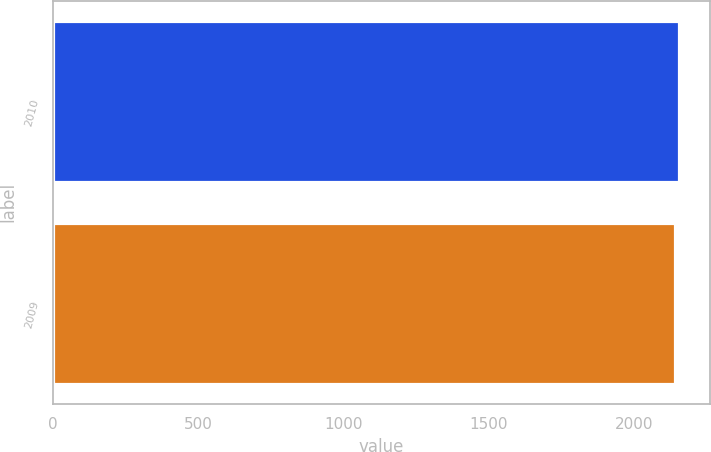<chart> <loc_0><loc_0><loc_500><loc_500><bar_chart><fcel>2010<fcel>2009<nl><fcel>2155.4<fcel>2142.8<nl></chart> 